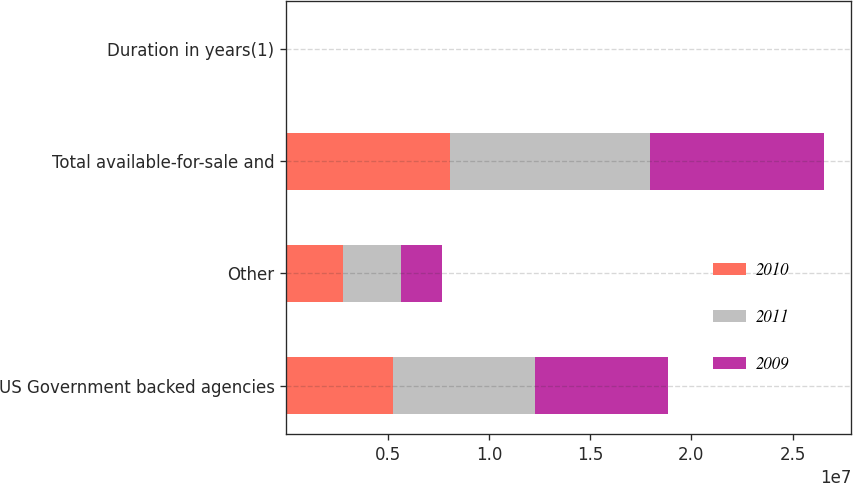<chart> <loc_0><loc_0><loc_500><loc_500><stacked_bar_chart><ecel><fcel>US Government backed agencies<fcel>Other<fcel>Total available-for-sale and<fcel>Duration in years(1)<nl><fcel>2010<fcel>5.25364e+06<fcel>2.82437e+06<fcel>8.07801e+06<fcel>3.1<nl><fcel>2011<fcel>7.04803e+06<fcel>2.84722e+06<fcel>9.89524e+06<fcel>3<nl><fcel>2009<fcel>6.56665e+06<fcel>2.02126e+06<fcel>8.58791e+06<fcel>2.4<nl></chart> 